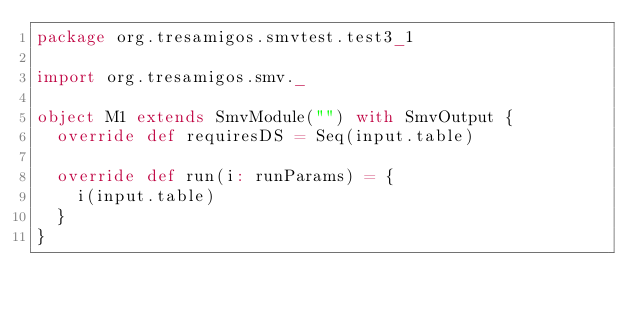<code> <loc_0><loc_0><loc_500><loc_500><_Scala_>package org.tresamigos.smvtest.test3_1

import org.tresamigos.smv._

object M1 extends SmvModule("") with SmvOutput {
  override def requiresDS = Seq(input.table)

  override def run(i: runParams) = {
    i(input.table)
  }
}
</code> 